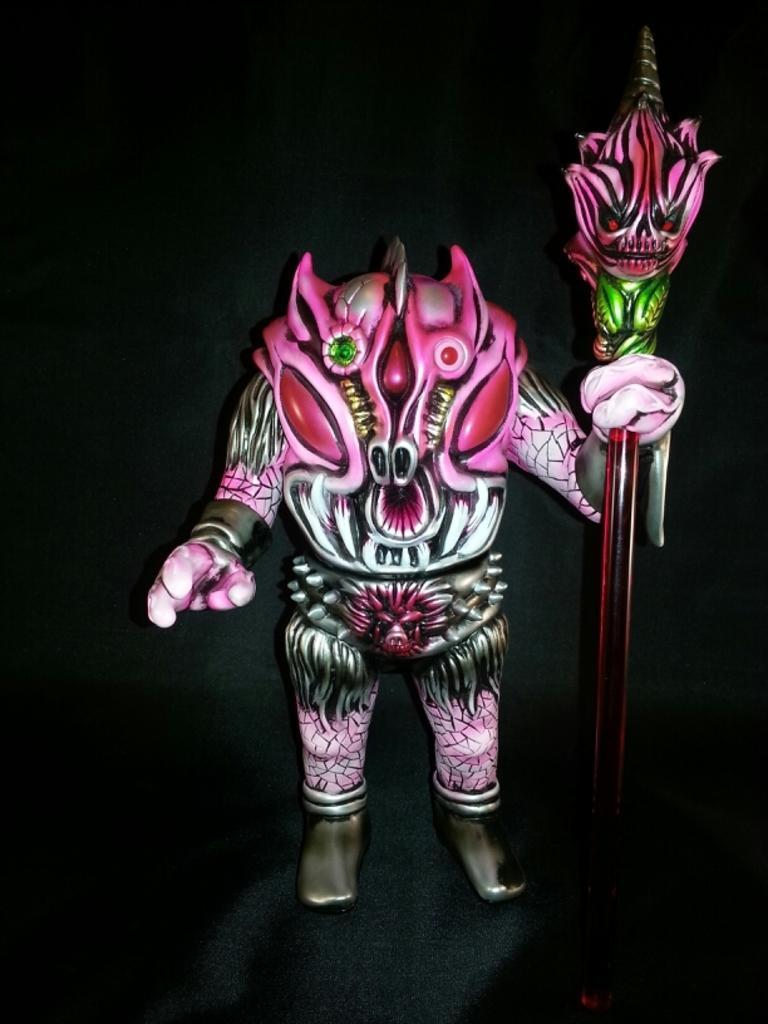How would you summarize this image in a sentence or two? In this image there is a demon holding some object. 